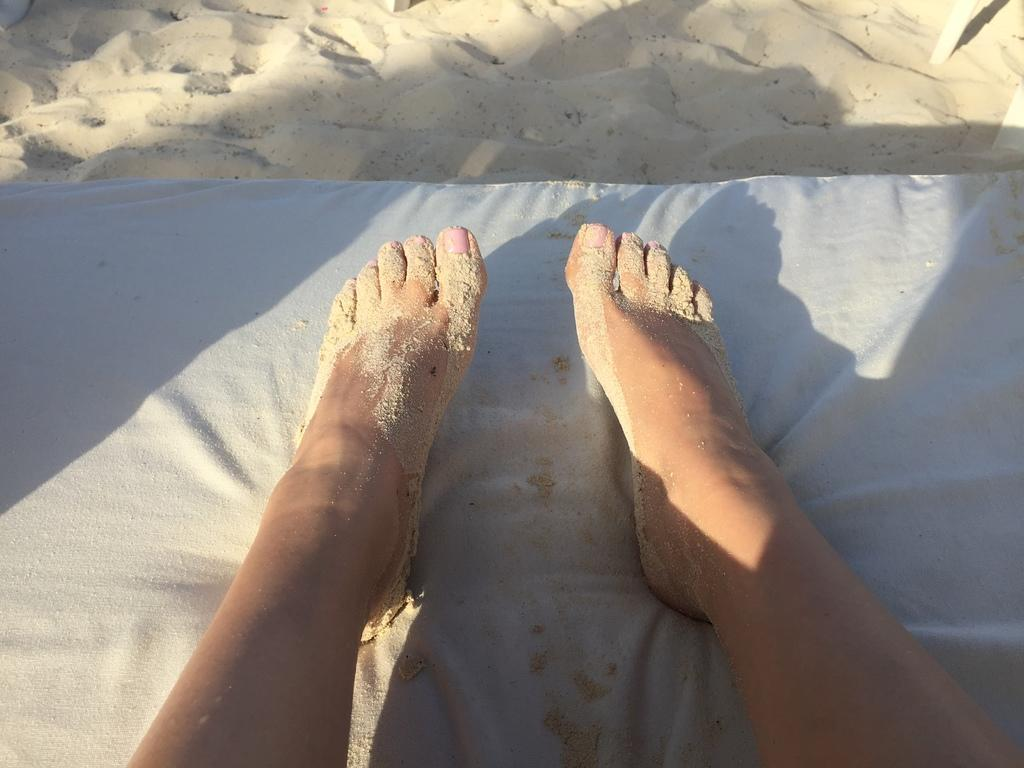What body part is visible in the image? There are a person's legs in the image. What type of terrain is present in the image? There is sand in the image. What material is present in the image? There is cloth in the image. How does the quartz affect the coastline in the image? There is no quartz or coastline present in the image; it only features a person's legs, sand, and cloth. 